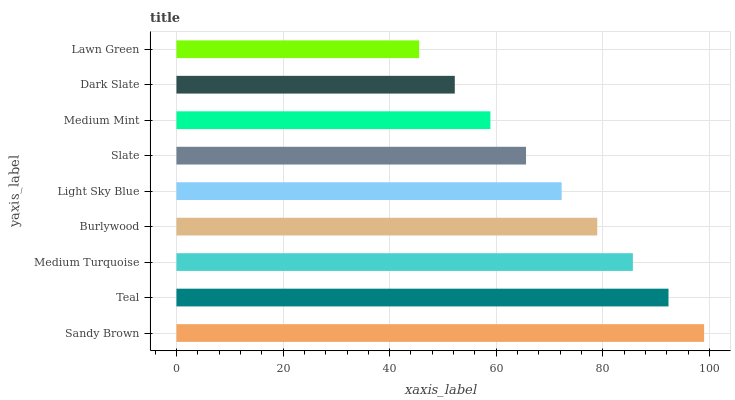Is Lawn Green the minimum?
Answer yes or no. Yes. Is Sandy Brown the maximum?
Answer yes or no. Yes. Is Teal the minimum?
Answer yes or no. No. Is Teal the maximum?
Answer yes or no. No. Is Sandy Brown greater than Teal?
Answer yes or no. Yes. Is Teal less than Sandy Brown?
Answer yes or no. Yes. Is Teal greater than Sandy Brown?
Answer yes or no. No. Is Sandy Brown less than Teal?
Answer yes or no. No. Is Light Sky Blue the high median?
Answer yes or no. Yes. Is Light Sky Blue the low median?
Answer yes or no. Yes. Is Teal the high median?
Answer yes or no. No. Is Medium Mint the low median?
Answer yes or no. No. 